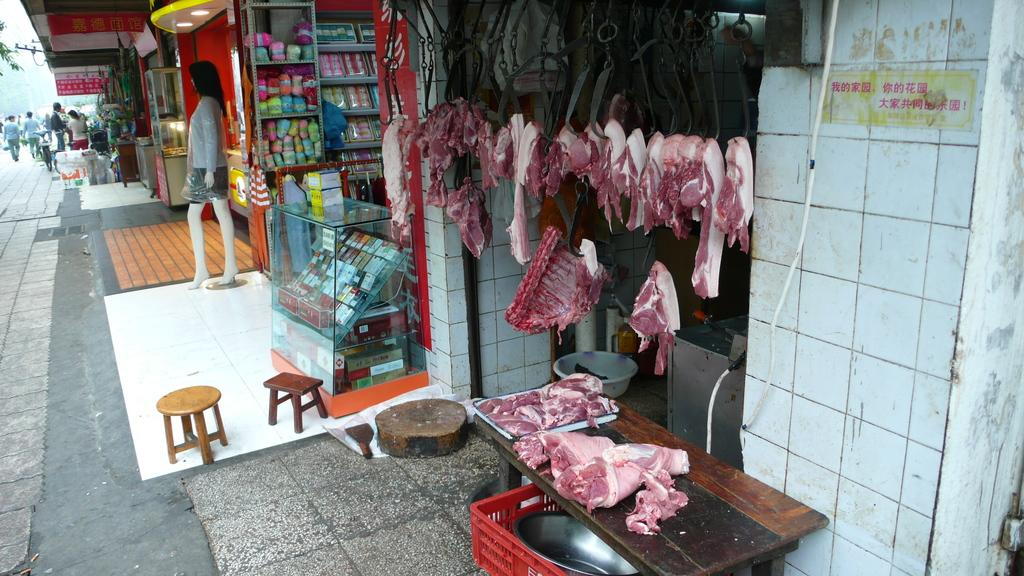What type of store is located on the right side of the image? There is a meat store on the right side of the image. What can be seen in the middle of the image? There are other stores visible in the middle of the image. What is on the left side of the image? There is a mannequin on the left side of the image. How many lizards are sitting on the mannequin in the image? There are no lizards present in the image. What is the boy doing in the image? There is no boy present in the image. 